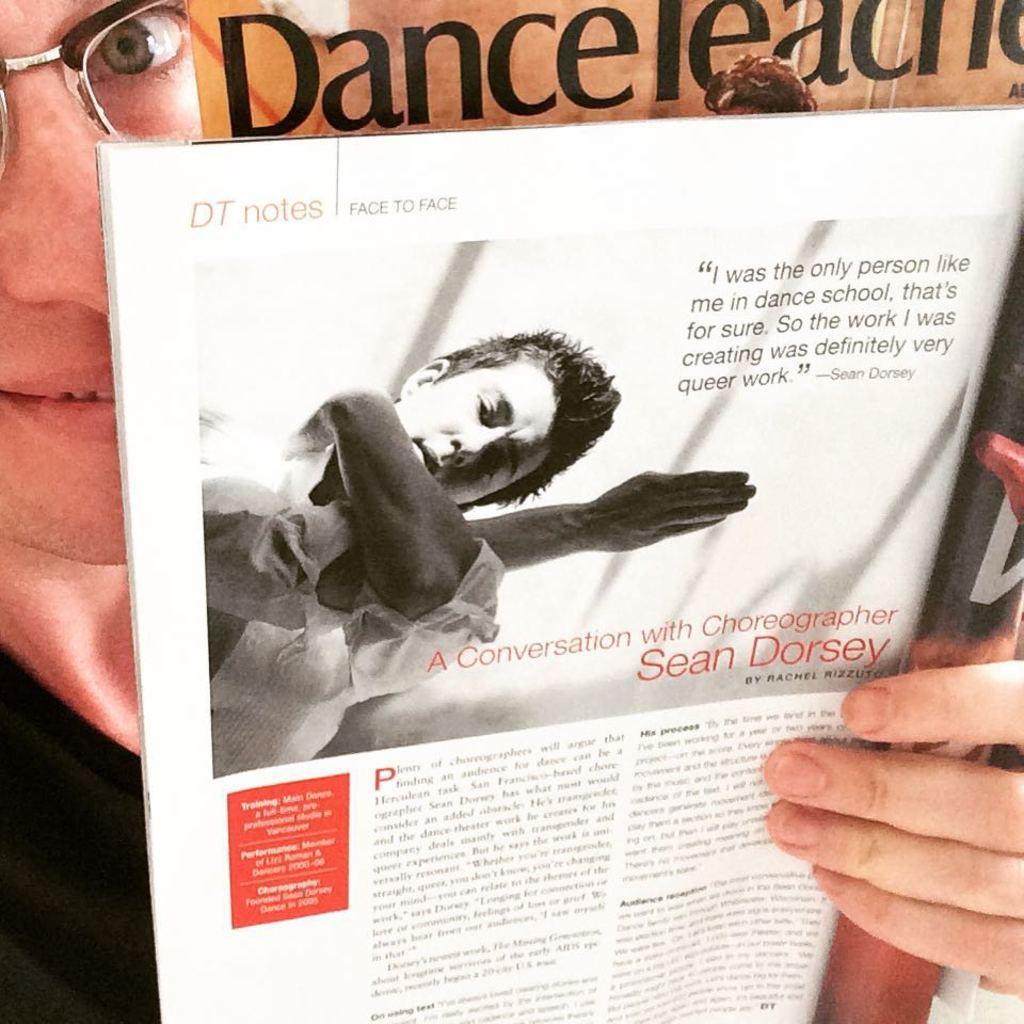Who's name is printed on this page after the line "a conversation with choreographer"?
Provide a succinct answer. Sean dorsey. What is printed in the top left corner?
Keep it short and to the point. Dt notes. 